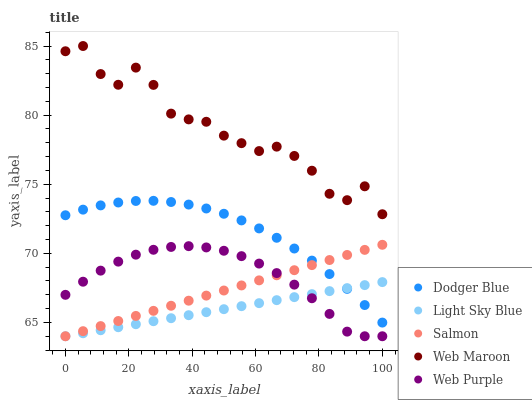Does Light Sky Blue have the minimum area under the curve?
Answer yes or no. Yes. Does Web Maroon have the maximum area under the curve?
Answer yes or no. Yes. Does Web Purple have the minimum area under the curve?
Answer yes or no. No. Does Web Purple have the maximum area under the curve?
Answer yes or no. No. Is Salmon the smoothest?
Answer yes or no. Yes. Is Web Maroon the roughest?
Answer yes or no. Yes. Is Web Purple the smoothest?
Answer yes or no. No. Is Web Purple the roughest?
Answer yes or no. No. Does Salmon have the lowest value?
Answer yes or no. Yes. Does Dodger Blue have the lowest value?
Answer yes or no. No. Does Web Maroon have the highest value?
Answer yes or no. Yes. Does Web Purple have the highest value?
Answer yes or no. No. Is Web Purple less than Web Maroon?
Answer yes or no. Yes. Is Web Maroon greater than Salmon?
Answer yes or no. Yes. Does Salmon intersect Dodger Blue?
Answer yes or no. Yes. Is Salmon less than Dodger Blue?
Answer yes or no. No. Is Salmon greater than Dodger Blue?
Answer yes or no. No. Does Web Purple intersect Web Maroon?
Answer yes or no. No. 